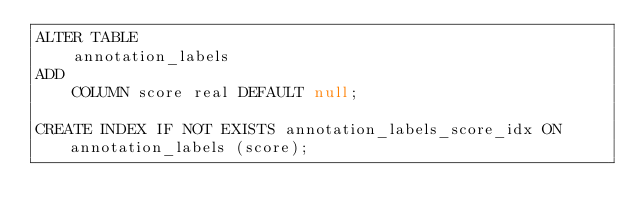<code> <loc_0><loc_0><loc_500><loc_500><_SQL_>ALTER TABLE
    annotation_labels
ADD
    COLUMN score real DEFAULT null;

CREATE INDEX IF NOT EXISTS annotation_labels_score_idx ON annotation_labels (score);</code> 